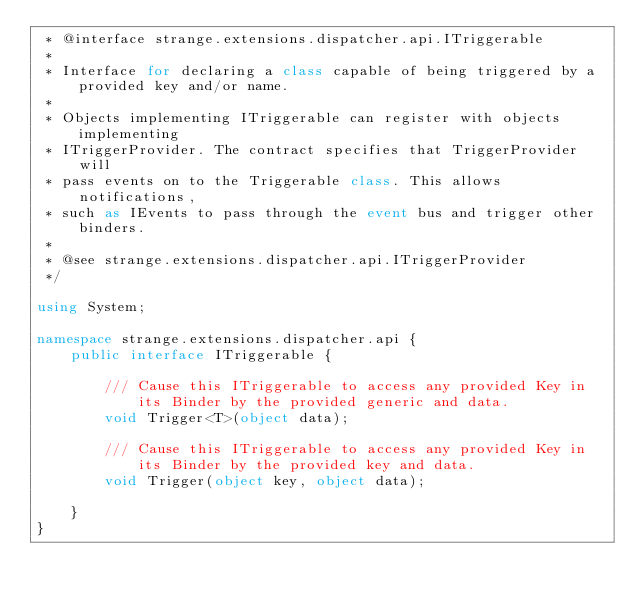Convert code to text. <code><loc_0><loc_0><loc_500><loc_500><_C#_> * @interface strange.extensions.dispatcher.api.ITriggerable
 * 
 * Interface for declaring a class capable of being triggered by a provided key and/or name.
 * 
 * Objects implementing ITriggerable can register with objects implementing
 * ITriggerProvider. The contract specifies that TriggerProvider will
 * pass events on to the Triggerable class. This allows notifications,
 * such as IEvents to pass through the event bus and trigger other binders.
 * 
 * @see strange.extensions.dispatcher.api.ITriggerProvider
 */

using System;

namespace strange.extensions.dispatcher.api {
    public interface ITriggerable {

        /// Cause this ITriggerable to access any provided Key in its Binder by the provided generic and data.
        void Trigger<T>(object data);

        /// Cause this ITriggerable to access any provided Key in its Binder by the provided key and data.
        void Trigger(object key, object data);

    }
}

</code> 